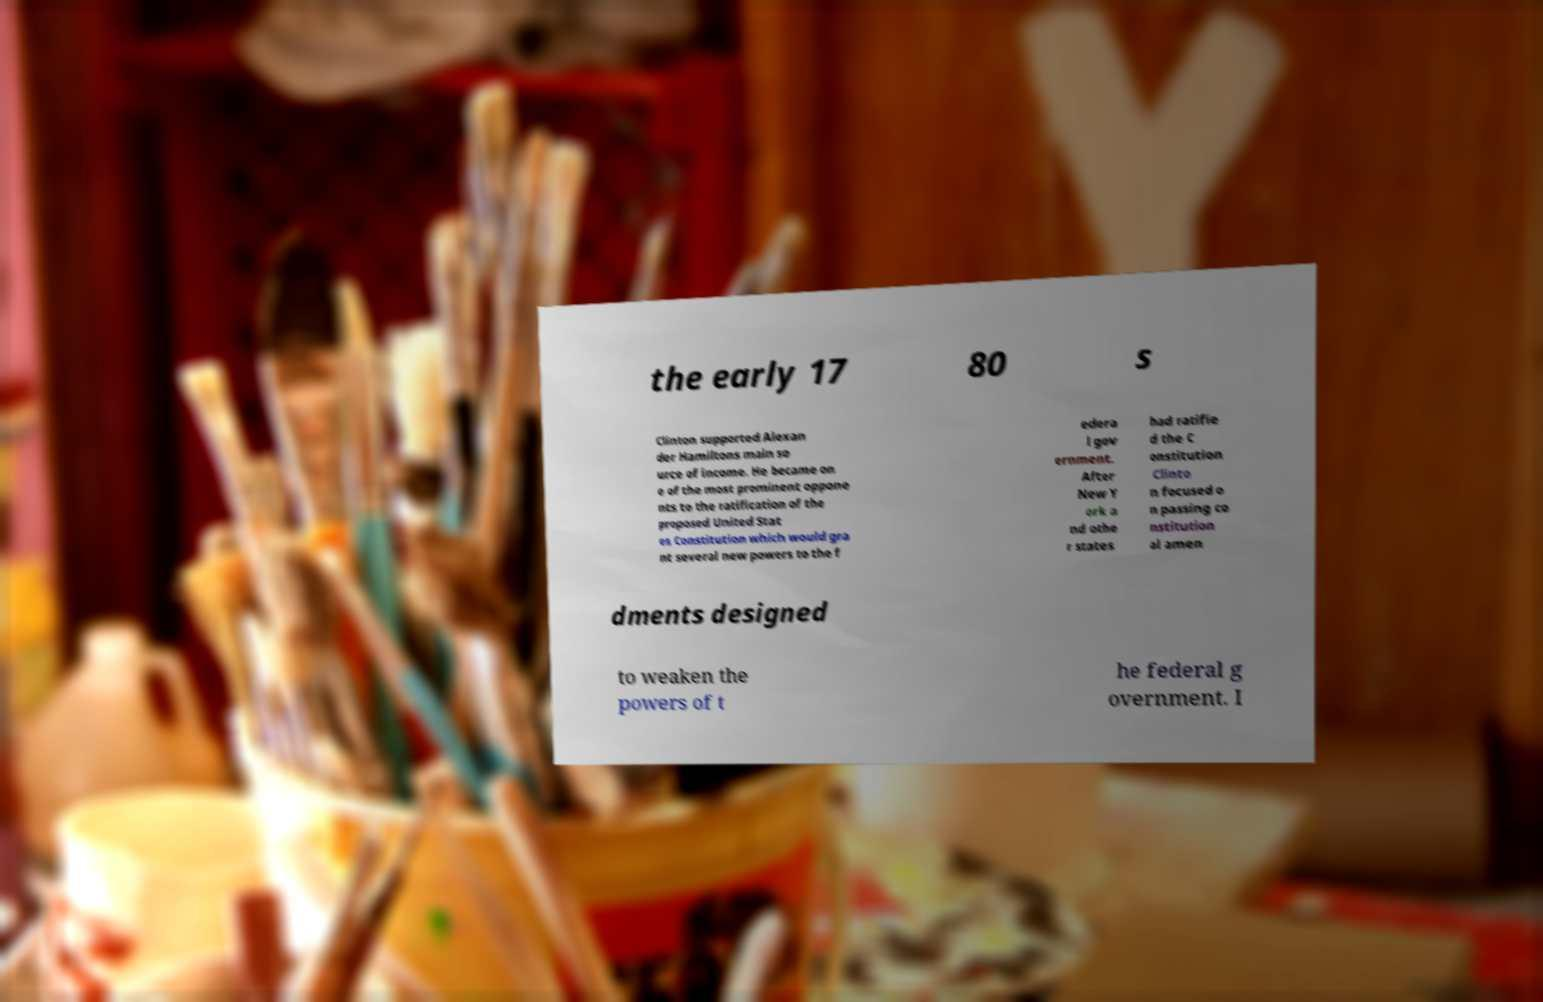Please identify and transcribe the text found in this image. the early 17 80 s Clinton supported Alexan der Hamiltons main so urce of income. He became on e of the most prominent oppone nts to the ratification of the proposed United Stat es Constitution which would gra nt several new powers to the f edera l gov ernment. After New Y ork a nd othe r states had ratifie d the C onstitution Clinto n focused o n passing co nstitution al amen dments designed to weaken the powers of t he federal g overnment. I 